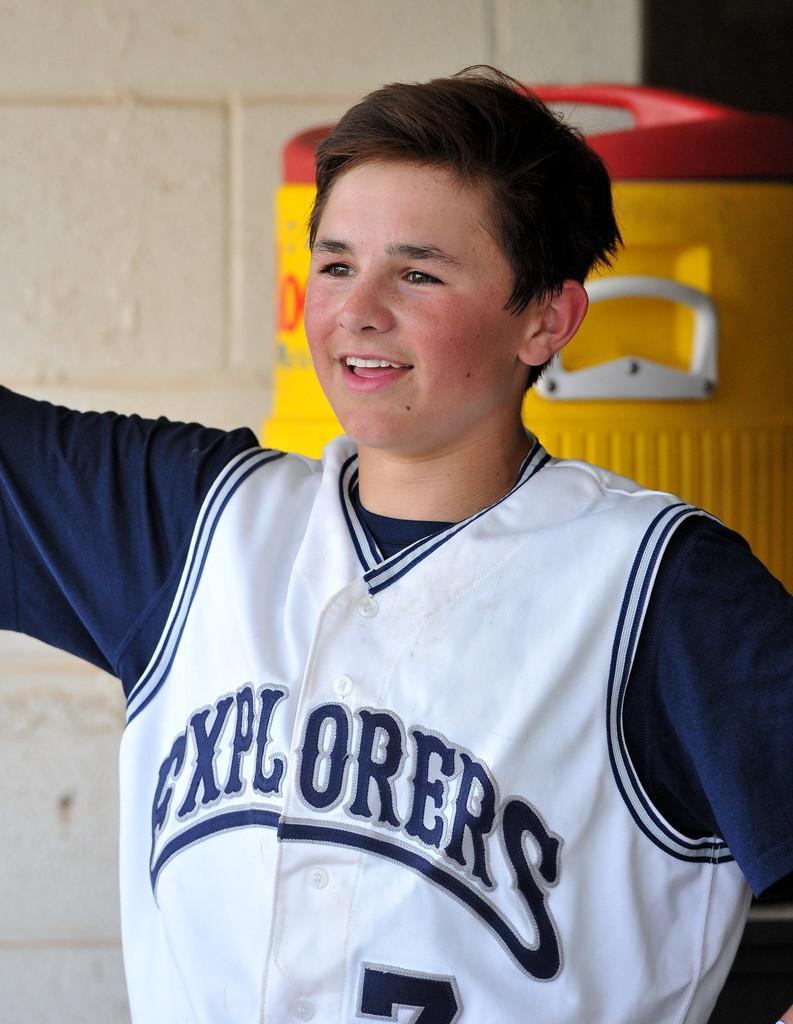Can you describe this image briefly? In the middle of the image there is a boy and he is with a smiling face. In the background there is a wall and there is an object. 